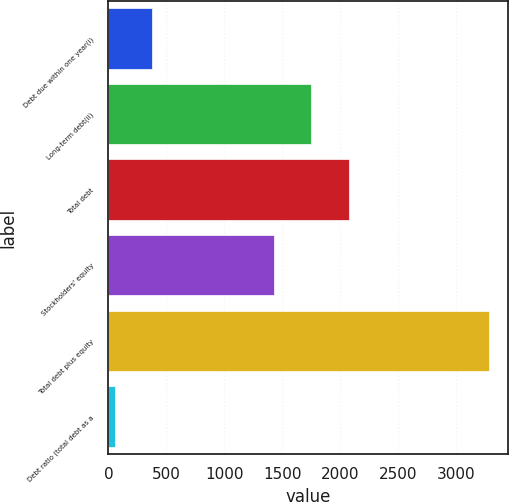<chart> <loc_0><loc_0><loc_500><loc_500><bar_chart><fcel>Debt due within one year(i)<fcel>Long-term debt(ii)<fcel>Total debt<fcel>Stockholders' equity<fcel>Total debt plus equity<fcel>Debt ratio (total debt as a<nl><fcel>379.62<fcel>1749.22<fcel>2072.24<fcel>1426.2<fcel>3286.8<fcel>56.6<nl></chart> 